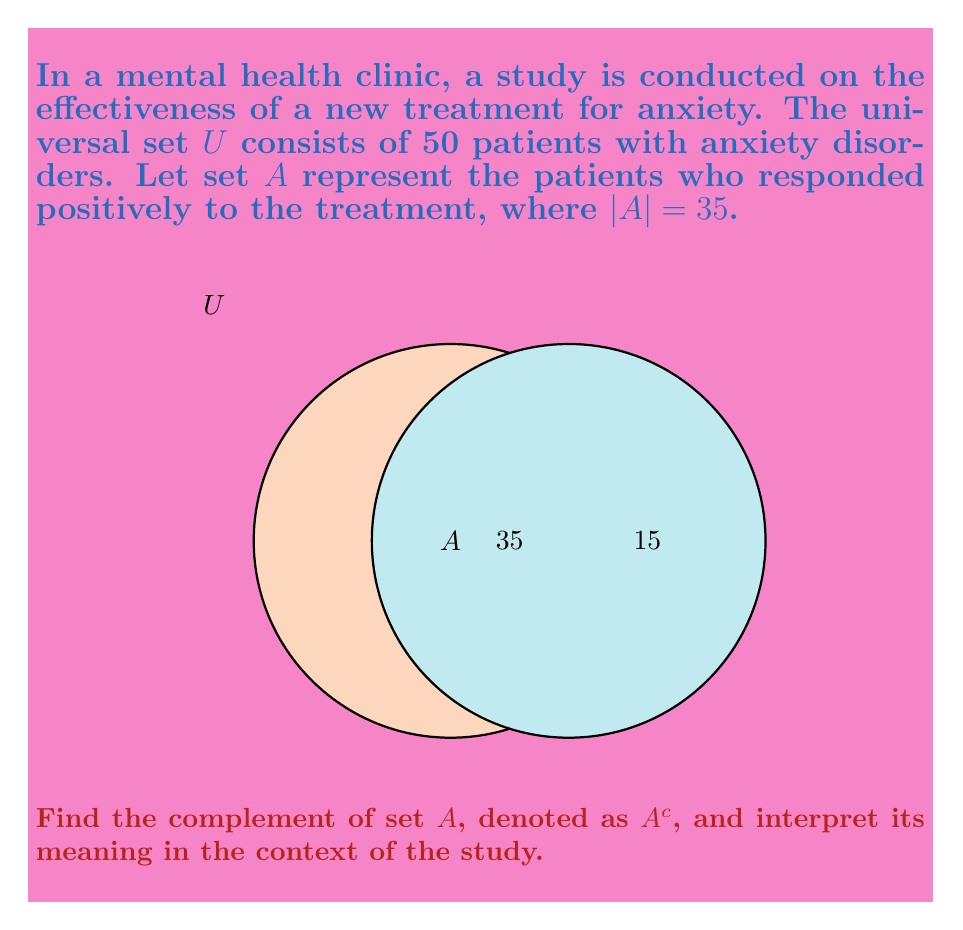Teach me how to tackle this problem. Let's approach this step-by-step:

1) First, recall that the complement of a set $A$, denoted as $A^c$, is the set of all elements in the universal set $U$ that are not in $A$.

2) We know that:
   - The universal set $U$ contains 50 patients
   - Set $A$ contains 35 patients who responded positively to the treatment

3) To find $A^c$, we need to subtract the number of elements in $A$ from the total number of elements in $U$:

   $$|A^c| = |U| - |A| = 50 - 35 = 15$$

4) Therefore, $A^c$ contains 15 patients.

5) Interpretation: $A^c$ represents the set of patients who did not respond positively to the treatment. These could be patients who showed no improvement or potentially even worsened.

This information is crucial for you as an aspiring mental health professional, as it helps in understanding the effectiveness of the treatment and identifying patients who may need alternative interventions.
Answer: $A^c = \{x \in U : x \notin A\}$, where $|A^c| = 15$ 